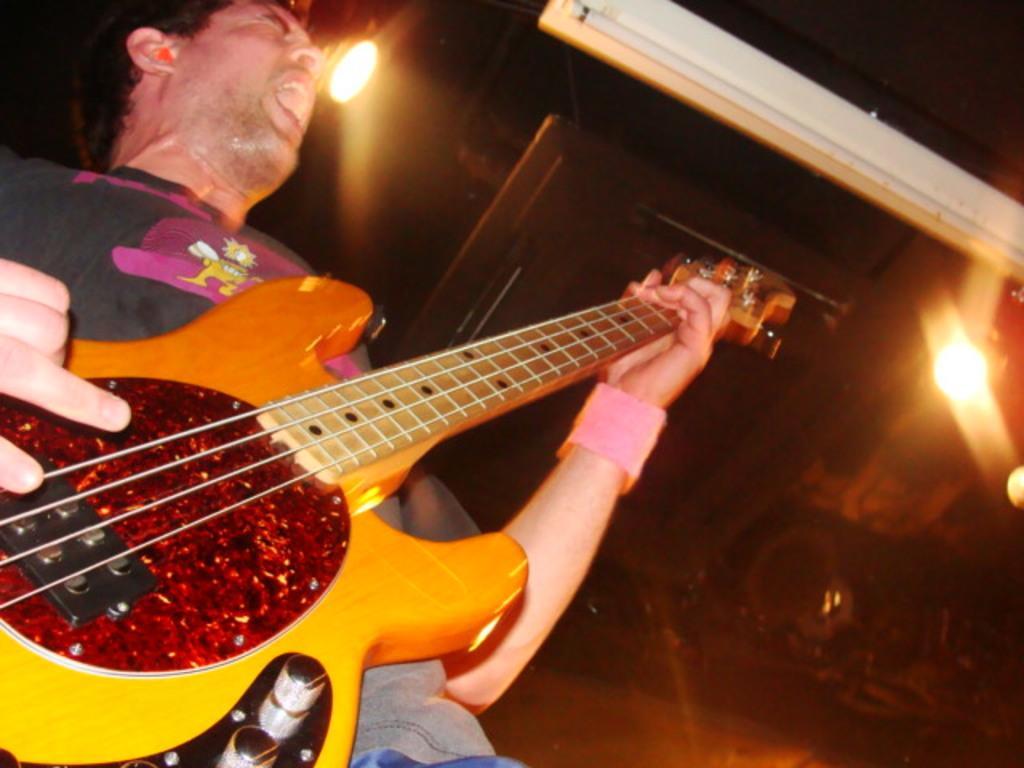Please provide a concise description of this image. There is a man who is playing guitar. There are lights and this is floor. 